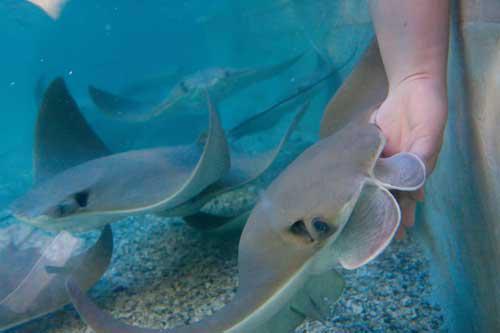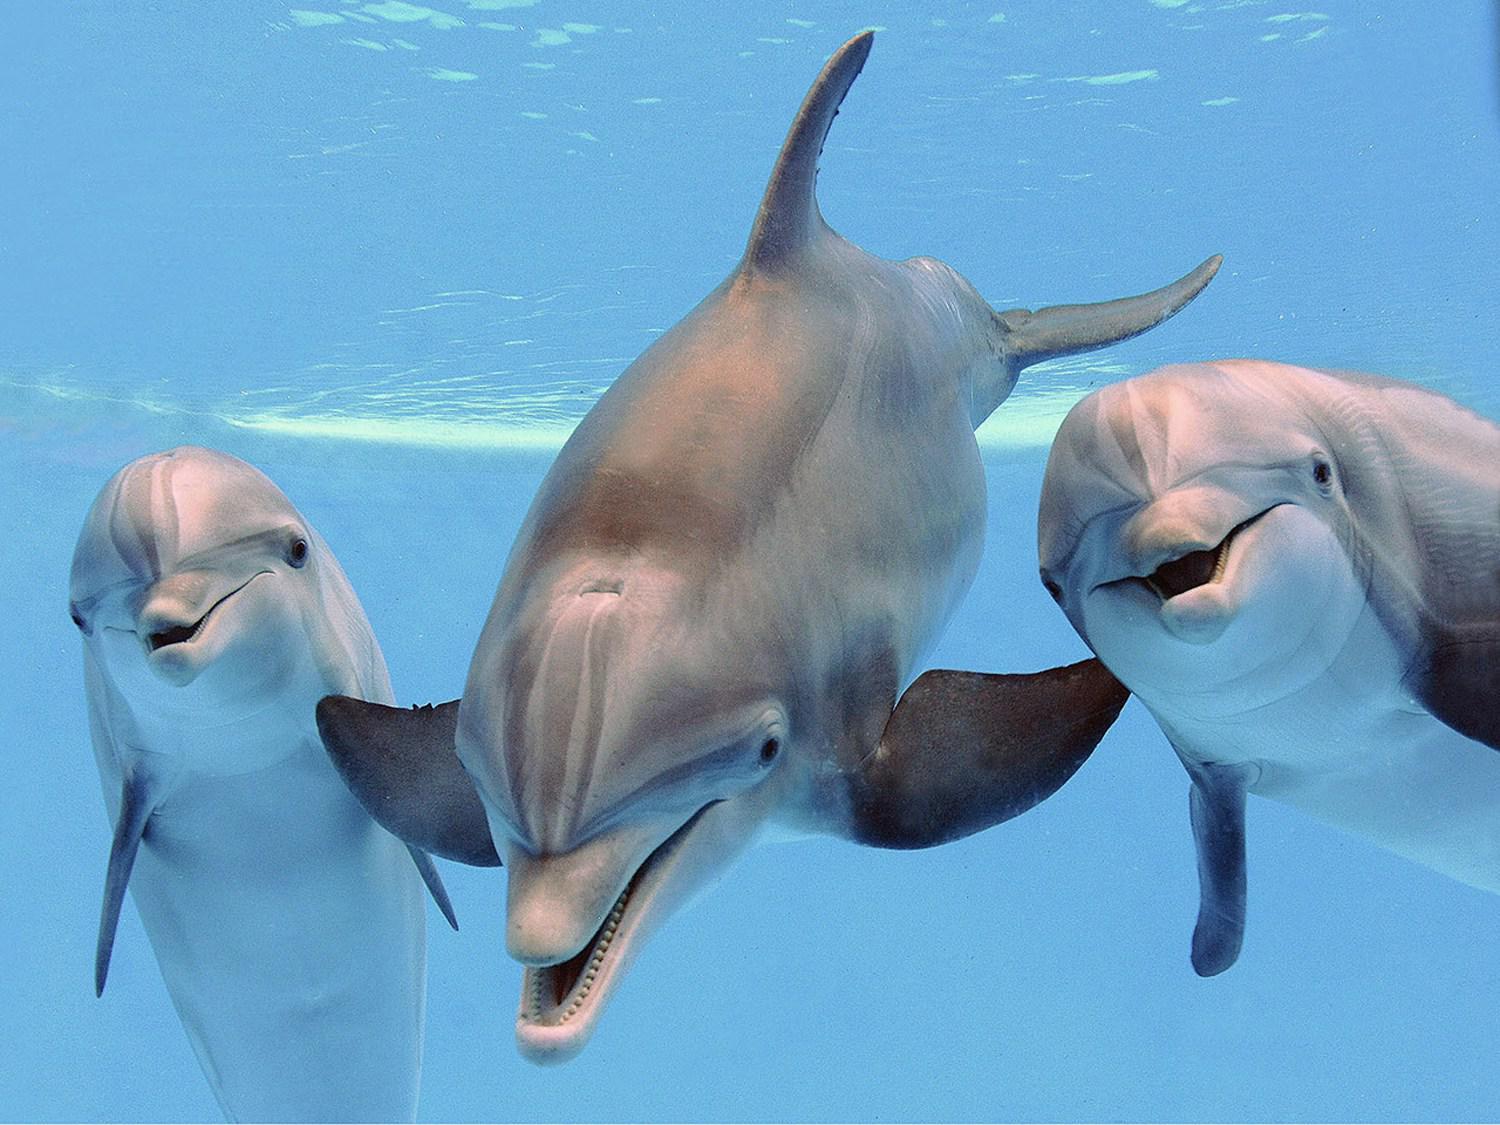The first image is the image on the left, the second image is the image on the right. Considering the images on both sides, is "A person is touching a ray with their hand." valid? Answer yes or no. Yes. The first image is the image on the left, the second image is the image on the right. For the images displayed, is the sentence "The image on the left contains a persons hand stroking a small string ray." factually correct? Answer yes or no. Yes. 